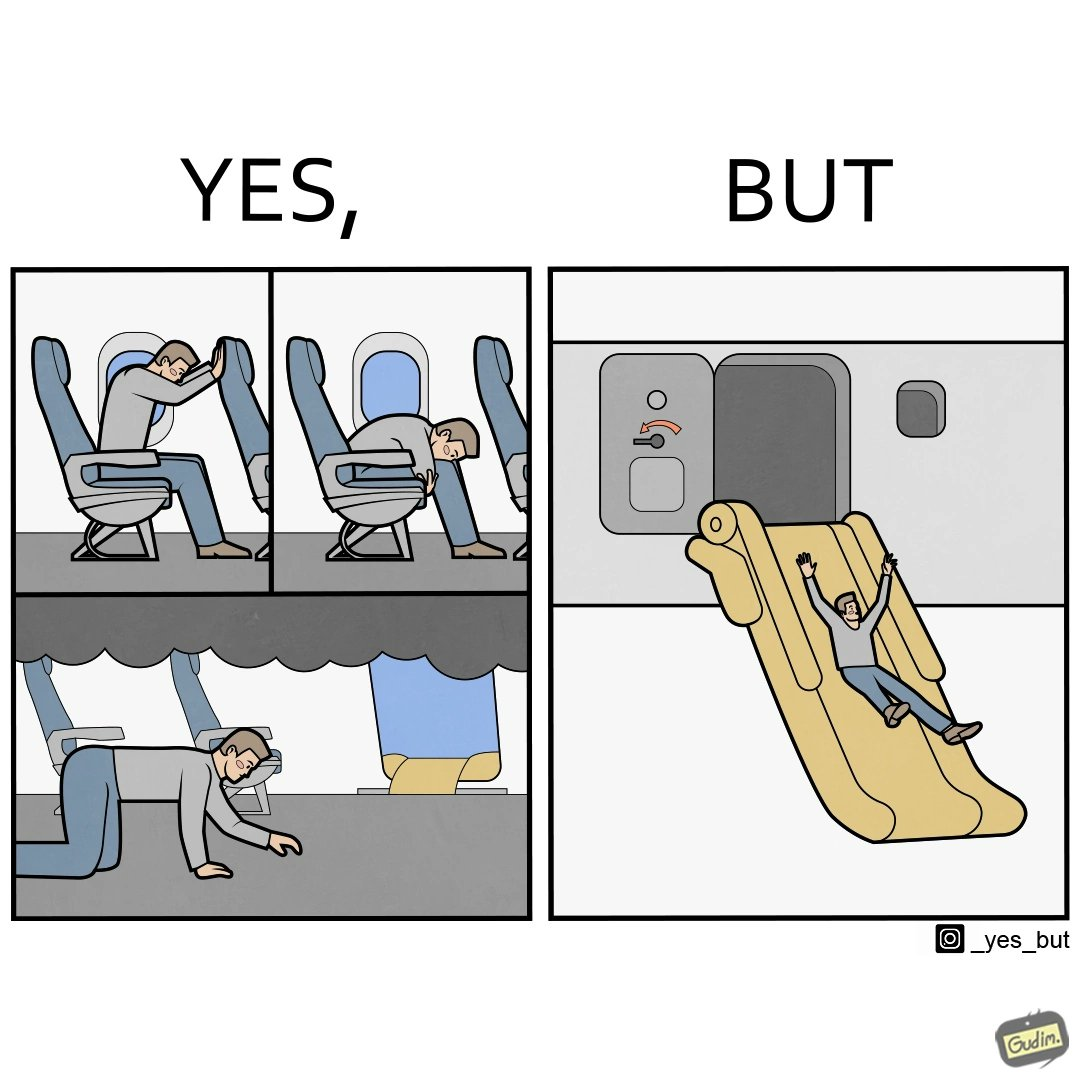Provide a description of this image. These images are funny since it shows how we are taught emergency procedures to follow in case of an accident while in an airplane but how none of them work if the plane is still in air 